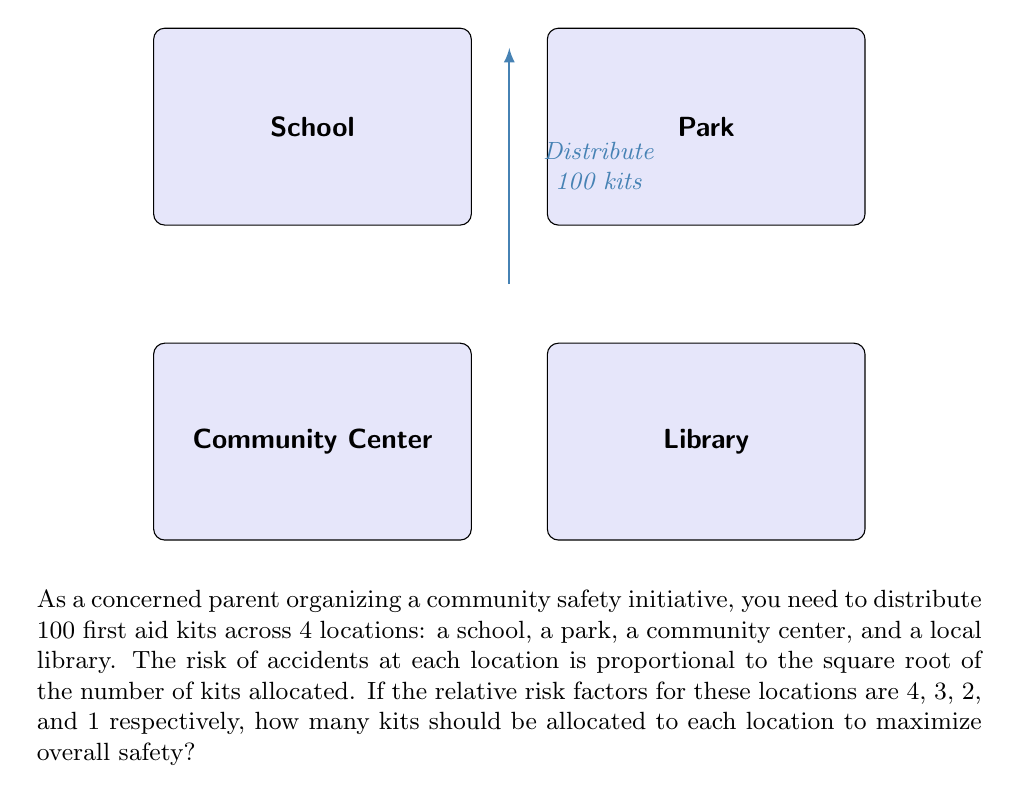Give your solution to this math problem. Let's approach this step-by-step using the principle of marginal analysis in Operations Research:

1) Let $x_1$, $x_2$, $x_3$, and $x_4$ be the number of kits allocated to the school, park, community center, and library respectively.

2) The objective function to maximize is:

   $$4\sqrt{x_1} + 3\sqrt{x_2} + 2\sqrt{x_3} + \sqrt{x_4}$$

3) Subject to the constraint:

   $$x_1 + x_2 + x_3 + x_4 = 100$$

4) For optimal allocation, the marginal benefit per kit should be equal across all locations. This means:

   $$\frac{4}{2\sqrt{x_1}} = \frac{3}{2\sqrt{x_2}} = \frac{2}{2\sqrt{x_3}} = \frac{1}{2\sqrt{x_4}}$$

5) From this, we can deduce:

   $$\frac{x_2}{x_1} = (\frac{3}{4})^2 = \frac{9}{16}$$
   $$\frac{x_3}{x_1} = (\frac{2}{4})^2 = \frac{1}{4}$$
   $$\frac{x_4}{x_1} = (\frac{1}{4})^2 = \frac{1}{16}$$

6) Let $x_1 = 16k$. Then:
   $x_2 = 9k$
   $x_3 = 4k$
   $x_4 = k$

7) Substituting into the constraint equation:

   $$16k + 9k + 4k + k = 100$$
   $$30k = 100$$
   $$k = \frac{10}{3}$$

8) Therefore:
   $x_1 = 16 * \frac{10}{3} \approx 53.33$
   $x_2 = 9 * \frac{10}{3} = 30$
   $x_3 = 4 * \frac{10}{3} \approx 13.33$
   $x_4 = \frac{10}{3} \approx 3.33$

9) Rounding to the nearest whole number (as we can't distribute partial kits):
   School: 53 kits
   Park: 30 kits
   Community Center: 13 kits
   Library: 4 kits
Answer: School: 53, Park: 30, Community Center: 13, Library: 4 